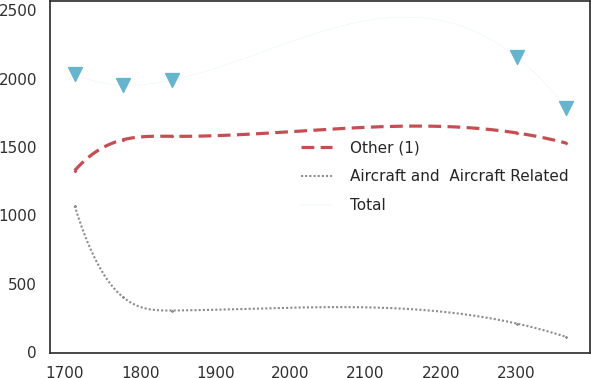Convert chart to OTSL. <chart><loc_0><loc_0><loc_500><loc_500><line_chart><ecel><fcel>Other (1)<fcel>Aircraft and  Aircraft Related<fcel>Total<nl><fcel>1712.9<fcel>1326.65<fcel>1069.6<fcel>2031.38<nl><fcel>1777.72<fcel>1553.63<fcel>398.55<fcel>1953.37<nl><fcel>1842.54<fcel>1578.07<fcel>302.59<fcel>1990.26<nl><fcel>2301.73<fcel>1602.51<fcel>206.63<fcel>2156.39<nl><fcel>2366.55<fcel>1529.19<fcel>109.95<fcel>1787.49<nl></chart> 